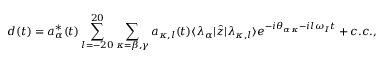Convert formula to latex. <formula><loc_0><loc_0><loc_500><loc_500>d ( t ) = a _ { \alpha } ^ { \ast } ( t ) \sum _ { l = - 2 0 } ^ { 2 0 } \sum _ { \kappa = \beta , \gamma } a _ { \kappa , l } ( t ) \langle \lambda _ { \alpha } | \hat { z } | \lambda _ { \kappa , l } \rangle e ^ { - i \theta _ { \alpha \kappa } - i l \omega _ { I } t } + c . c . ,</formula> 